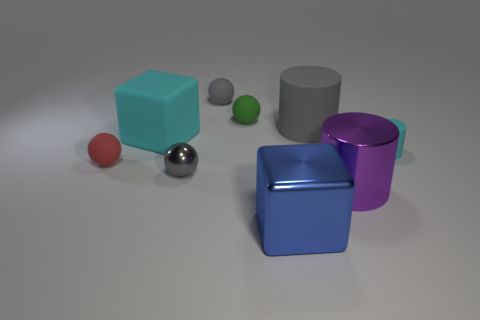Does this image convey anything about lighting and shadows? Yes, the image displays a setting with soft, diffused lighting that creates gentle shadows beneath each object. This suggests a source of light coming from the upper left, providing a calm and balanced composition. 